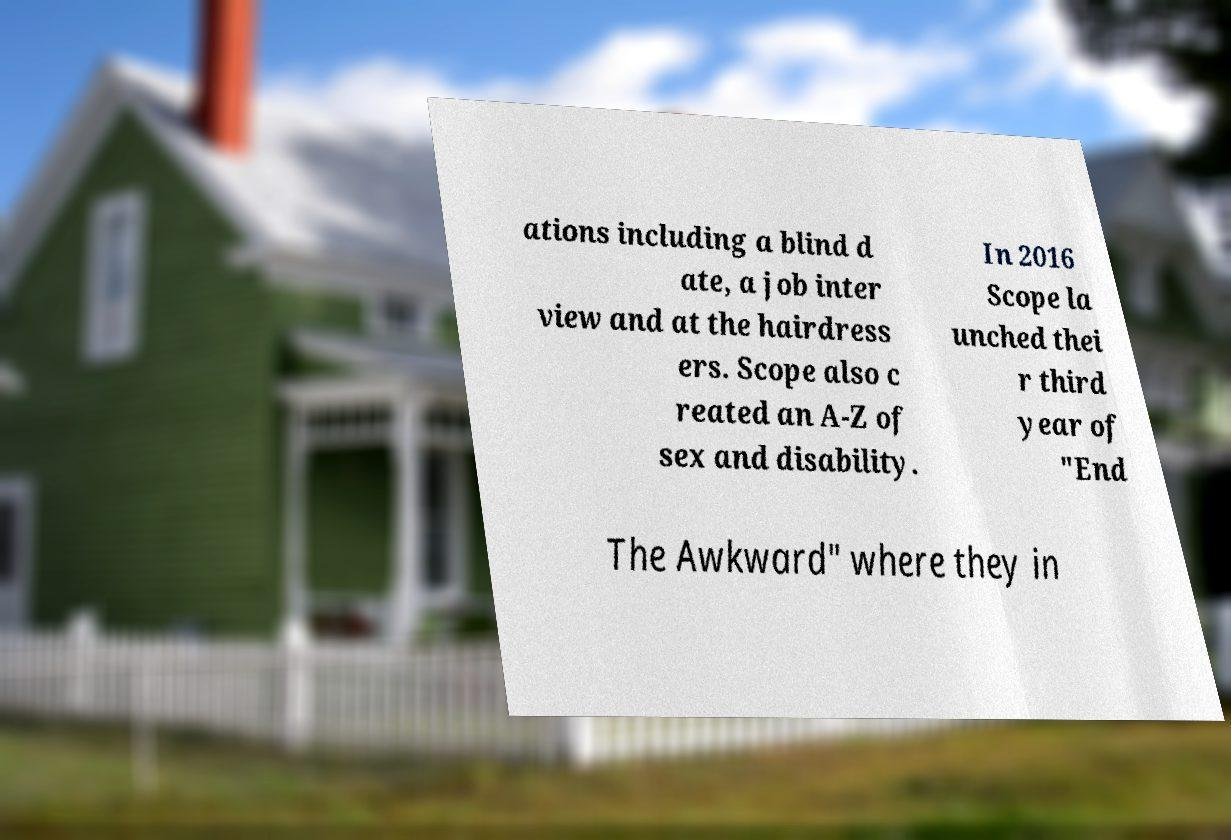Can you accurately transcribe the text from the provided image for me? ations including a blind d ate, a job inter view and at the hairdress ers. Scope also c reated an A-Z of sex and disability. In 2016 Scope la unched thei r third year of "End The Awkward" where they in 